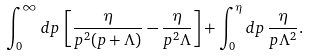<formula> <loc_0><loc_0><loc_500><loc_500>\int _ { 0 } ^ { \infty } d p \, \left [ \frac { \eta } { p ^ { 2 } ( p + \Lambda ) } - \frac { \eta } { p ^ { 2 } \Lambda } \right ] + \int _ { 0 } ^ { \eta } d p \, \frac { \eta } { p \Lambda ^ { 2 } } .</formula> 